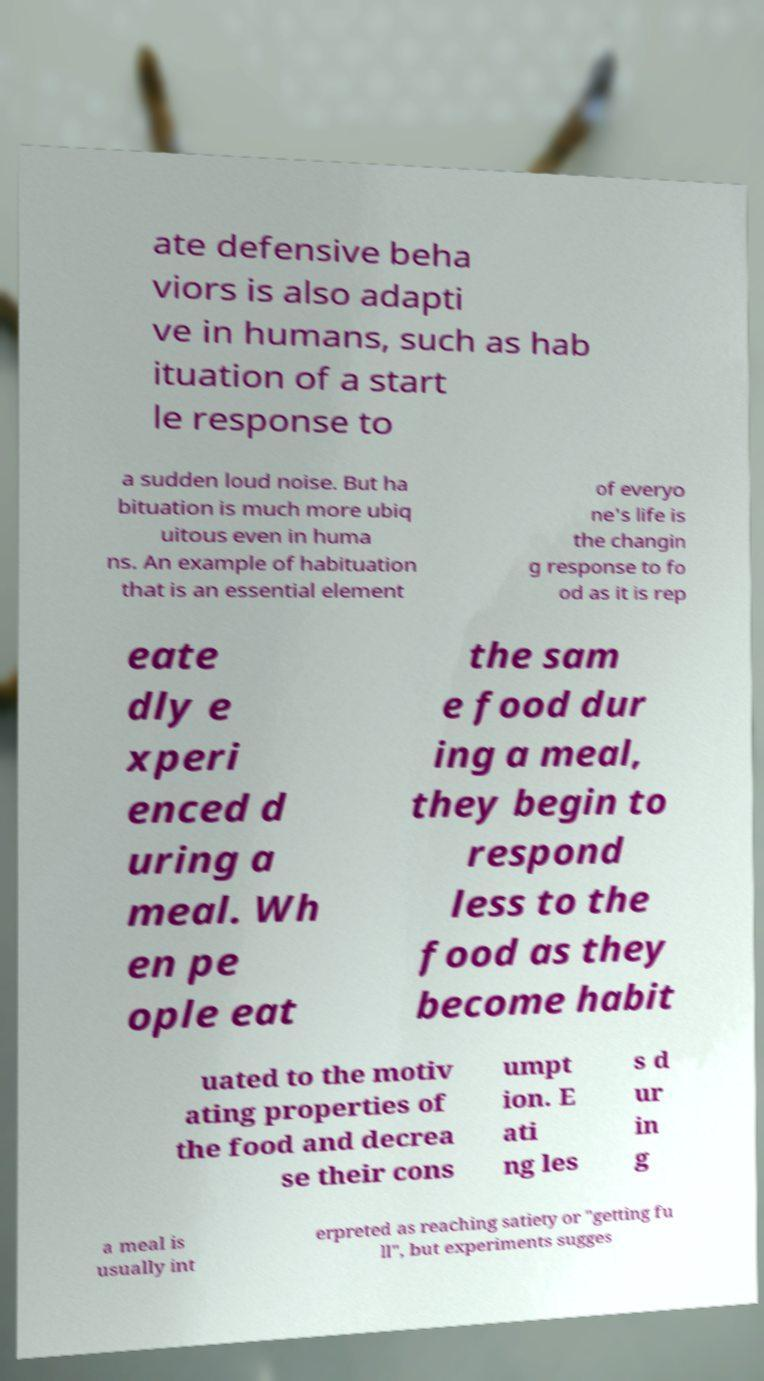I need the written content from this picture converted into text. Can you do that? ate defensive beha viors is also adapti ve in humans, such as hab ituation of a start le response to a sudden loud noise. But ha bituation is much more ubiq uitous even in huma ns. An example of habituation that is an essential element of everyo ne's life is the changin g response to fo od as it is rep eate dly e xperi enced d uring a meal. Wh en pe ople eat the sam e food dur ing a meal, they begin to respond less to the food as they become habit uated to the motiv ating properties of the food and decrea se their cons umpt ion. E ati ng les s d ur in g a meal is usually int erpreted as reaching satiety or "getting fu ll", but experiments sugges 